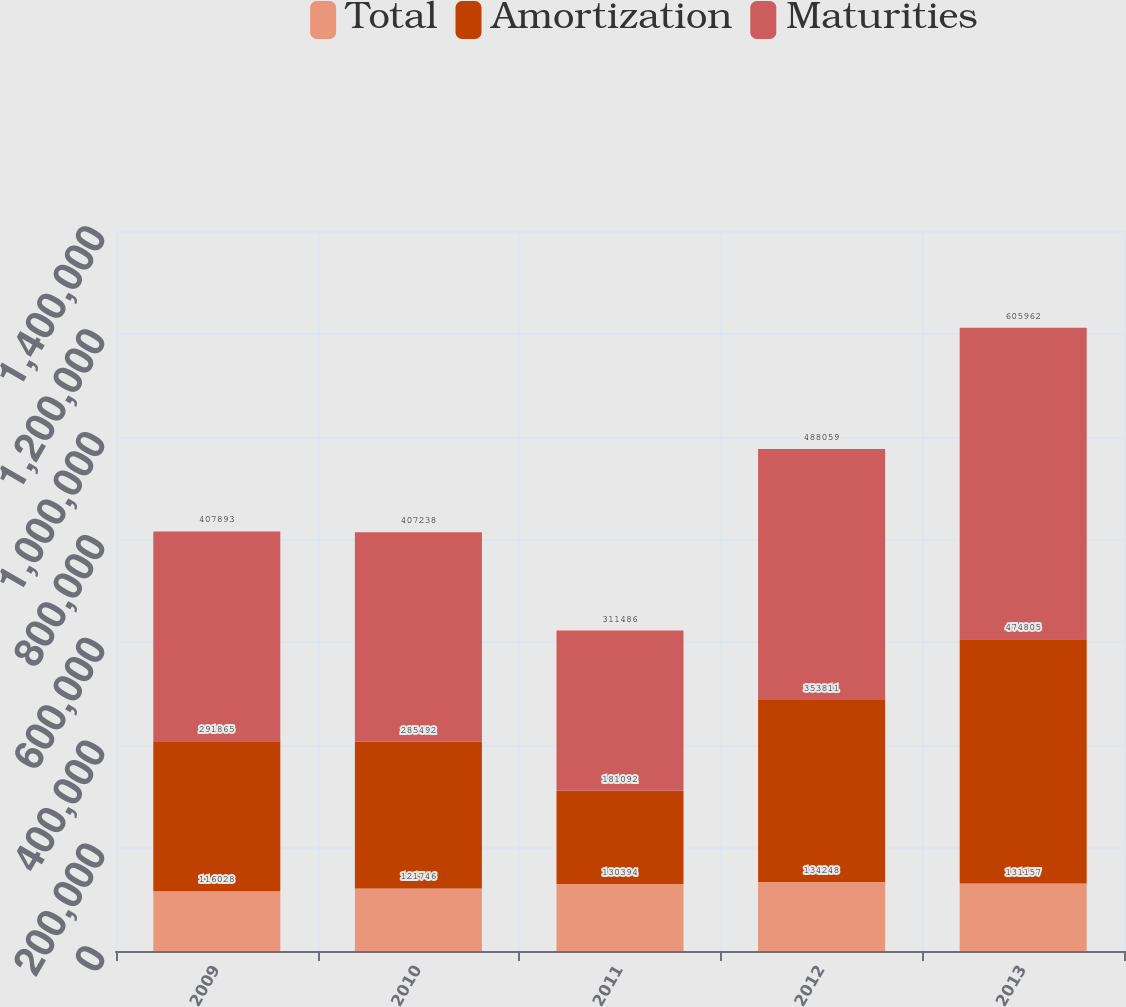Convert chart to OTSL. <chart><loc_0><loc_0><loc_500><loc_500><stacked_bar_chart><ecel><fcel>2009<fcel>2010<fcel>2011<fcel>2012<fcel>2013<nl><fcel>Total<fcel>116028<fcel>121746<fcel>130394<fcel>134248<fcel>131157<nl><fcel>Amortization<fcel>291865<fcel>285492<fcel>181092<fcel>353811<fcel>474805<nl><fcel>Maturities<fcel>407893<fcel>407238<fcel>311486<fcel>488059<fcel>605962<nl></chart> 